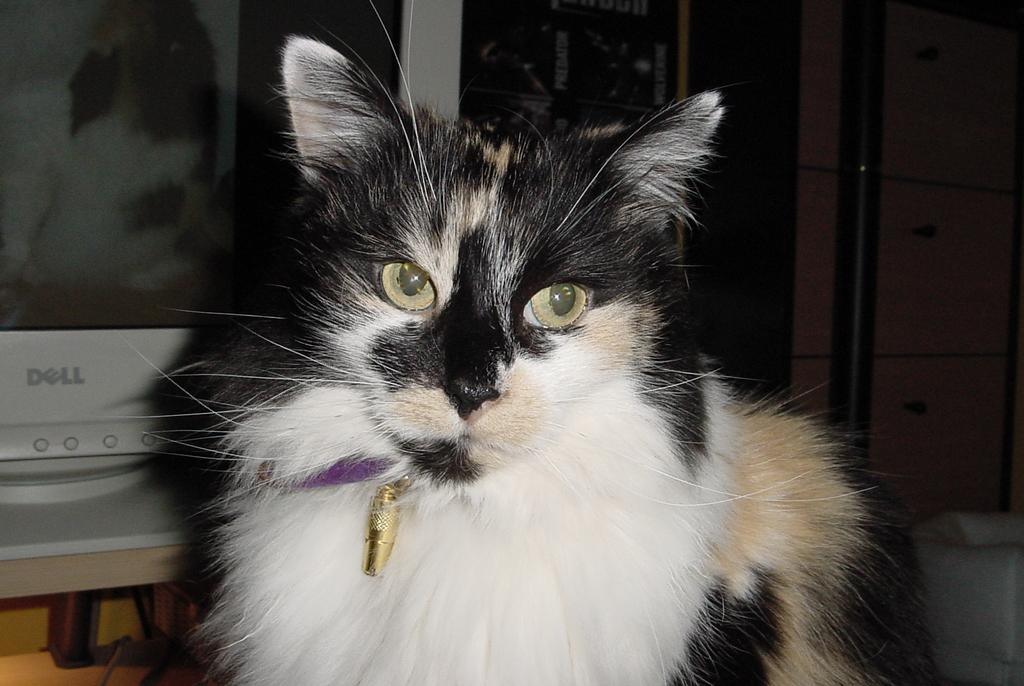<image>
Give a short and clear explanation of the subsequent image. A calico cat sits i front of a dell computer screen. 